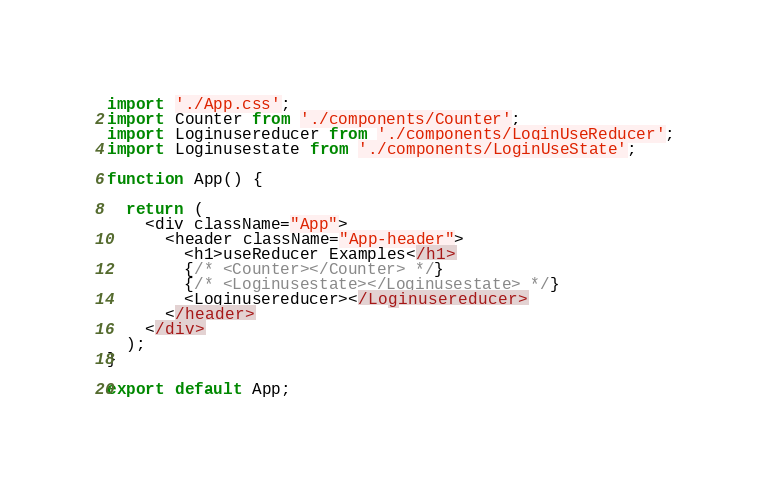Convert code to text. <code><loc_0><loc_0><loc_500><loc_500><_JavaScript_>import './App.css';
import Counter from './components/Counter';
import Loginusereducer from './components/LoginUseReducer';
import Loginusestate from './components/LoginUseState';

function App() {

  return (
    <div className="App">
      <header className="App-header">
        <h1>useReducer Examples</h1>
        {/* <Counter></Counter> */}
        {/* <Loginusestate></Loginusestate> */}
        <Loginusereducer></Loginusereducer>
      </header>
    </div>
  );
}

export default App;
</code> 